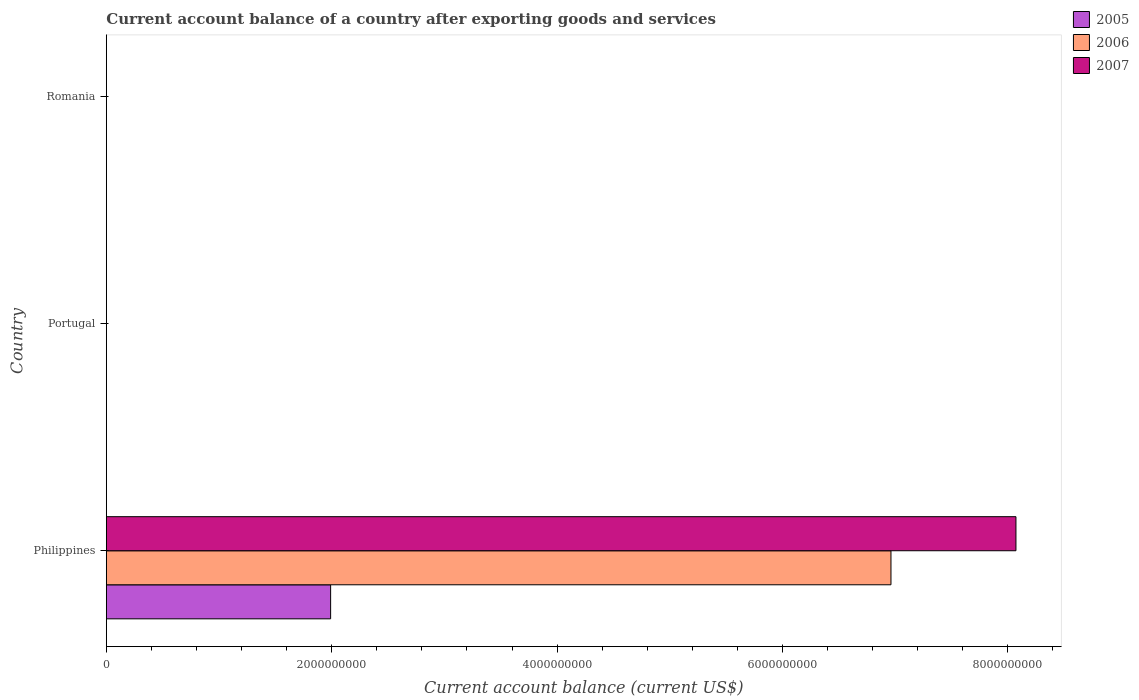How many different coloured bars are there?
Offer a very short reply. 3. Are the number of bars per tick equal to the number of legend labels?
Provide a succinct answer. No. Are the number of bars on each tick of the Y-axis equal?
Ensure brevity in your answer.  No. How many bars are there on the 3rd tick from the bottom?
Make the answer very short. 0. What is the label of the 2nd group of bars from the top?
Offer a terse response. Portugal. In how many cases, is the number of bars for a given country not equal to the number of legend labels?
Your answer should be compact. 2. What is the account balance in 2005 in Philippines?
Offer a very short reply. 1.99e+09. Across all countries, what is the maximum account balance in 2006?
Your response must be concise. 6.96e+09. Across all countries, what is the minimum account balance in 2007?
Your answer should be very brief. 0. In which country was the account balance in 2005 maximum?
Give a very brief answer. Philippines. What is the total account balance in 2006 in the graph?
Make the answer very short. 6.96e+09. What is the difference between the account balance in 2007 in Philippines and the account balance in 2006 in Portugal?
Give a very brief answer. 8.07e+09. What is the average account balance in 2006 per country?
Make the answer very short. 2.32e+09. What is the difference between the account balance in 2005 and account balance in 2007 in Philippines?
Keep it short and to the point. -6.08e+09. In how many countries, is the account balance in 2006 greater than 3600000000 US$?
Ensure brevity in your answer.  1. What is the difference between the highest and the lowest account balance in 2007?
Your response must be concise. 8.07e+09. In how many countries, is the account balance in 2005 greater than the average account balance in 2005 taken over all countries?
Give a very brief answer. 1. Where does the legend appear in the graph?
Make the answer very short. Top right. How many legend labels are there?
Offer a very short reply. 3. What is the title of the graph?
Make the answer very short. Current account balance of a country after exporting goods and services. What is the label or title of the X-axis?
Give a very brief answer. Current account balance (current US$). What is the Current account balance (current US$) in 2005 in Philippines?
Make the answer very short. 1.99e+09. What is the Current account balance (current US$) of 2006 in Philippines?
Your answer should be compact. 6.96e+09. What is the Current account balance (current US$) of 2007 in Philippines?
Provide a short and direct response. 8.07e+09. What is the Current account balance (current US$) of 2005 in Portugal?
Your answer should be compact. 0. What is the Current account balance (current US$) in 2006 in Portugal?
Your answer should be very brief. 0. Across all countries, what is the maximum Current account balance (current US$) of 2005?
Provide a short and direct response. 1.99e+09. Across all countries, what is the maximum Current account balance (current US$) in 2006?
Your answer should be very brief. 6.96e+09. Across all countries, what is the maximum Current account balance (current US$) of 2007?
Your answer should be compact. 8.07e+09. Across all countries, what is the minimum Current account balance (current US$) of 2006?
Your response must be concise. 0. Across all countries, what is the minimum Current account balance (current US$) of 2007?
Provide a short and direct response. 0. What is the total Current account balance (current US$) of 2005 in the graph?
Ensure brevity in your answer.  1.99e+09. What is the total Current account balance (current US$) in 2006 in the graph?
Offer a terse response. 6.96e+09. What is the total Current account balance (current US$) of 2007 in the graph?
Your answer should be very brief. 8.07e+09. What is the average Current account balance (current US$) of 2005 per country?
Make the answer very short. 6.63e+08. What is the average Current account balance (current US$) of 2006 per country?
Keep it short and to the point. 2.32e+09. What is the average Current account balance (current US$) in 2007 per country?
Ensure brevity in your answer.  2.69e+09. What is the difference between the Current account balance (current US$) in 2005 and Current account balance (current US$) in 2006 in Philippines?
Provide a short and direct response. -4.97e+09. What is the difference between the Current account balance (current US$) of 2005 and Current account balance (current US$) of 2007 in Philippines?
Keep it short and to the point. -6.08e+09. What is the difference between the Current account balance (current US$) in 2006 and Current account balance (current US$) in 2007 in Philippines?
Your response must be concise. -1.11e+09. What is the difference between the highest and the lowest Current account balance (current US$) of 2005?
Make the answer very short. 1.99e+09. What is the difference between the highest and the lowest Current account balance (current US$) in 2006?
Your answer should be very brief. 6.96e+09. What is the difference between the highest and the lowest Current account balance (current US$) of 2007?
Make the answer very short. 8.07e+09. 